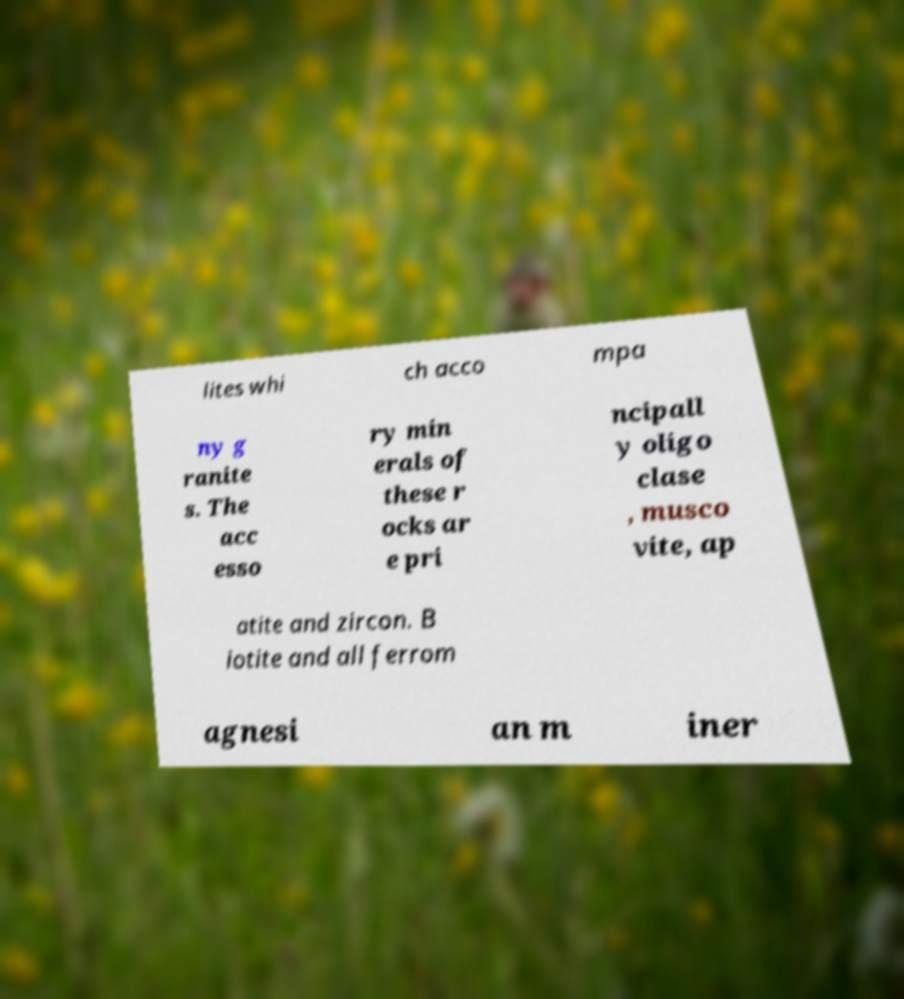I need the written content from this picture converted into text. Can you do that? lites whi ch acco mpa ny g ranite s. The acc esso ry min erals of these r ocks ar e pri ncipall y oligo clase , musco vite, ap atite and zircon. B iotite and all ferrom agnesi an m iner 